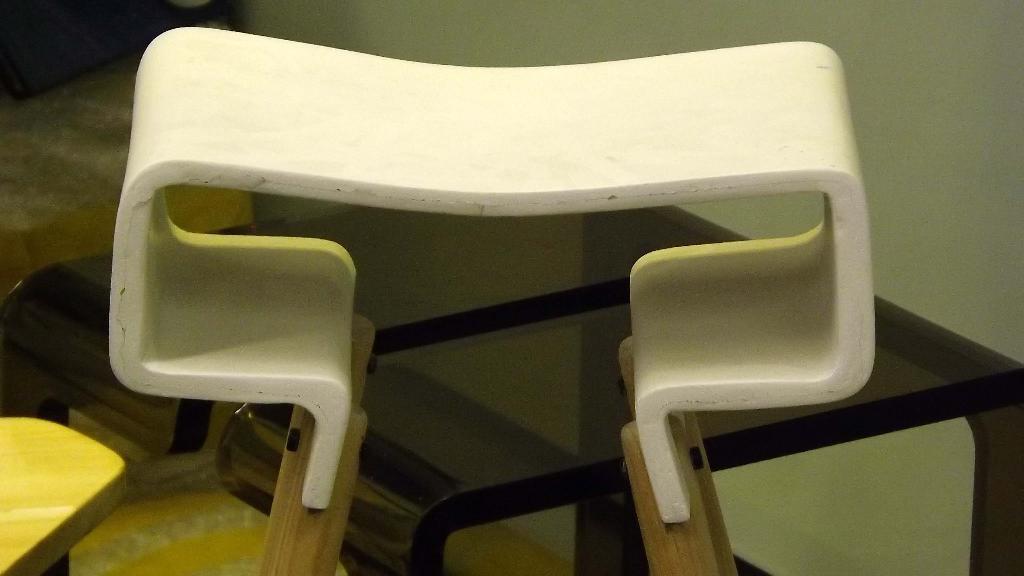Please provide a concise description of this image. In this image we can see a white color object, it maybe a table. 